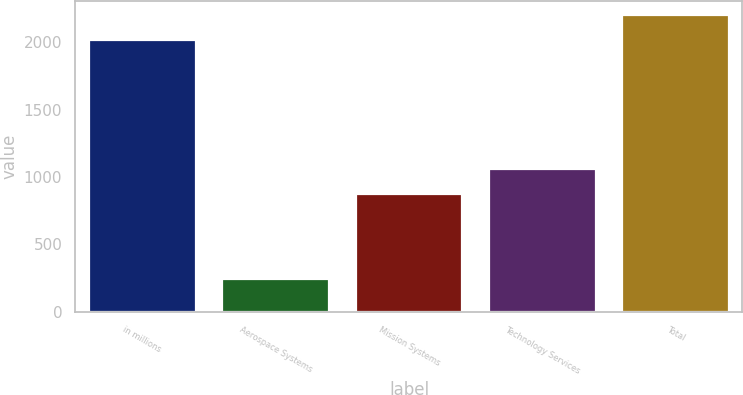Convert chart. <chart><loc_0><loc_0><loc_500><loc_500><bar_chart><fcel>in millions<fcel>Aerospace Systems<fcel>Mission Systems<fcel>Technology Services<fcel>Total<nl><fcel>2016<fcel>240<fcel>875<fcel>1058.3<fcel>2199.3<nl></chart> 